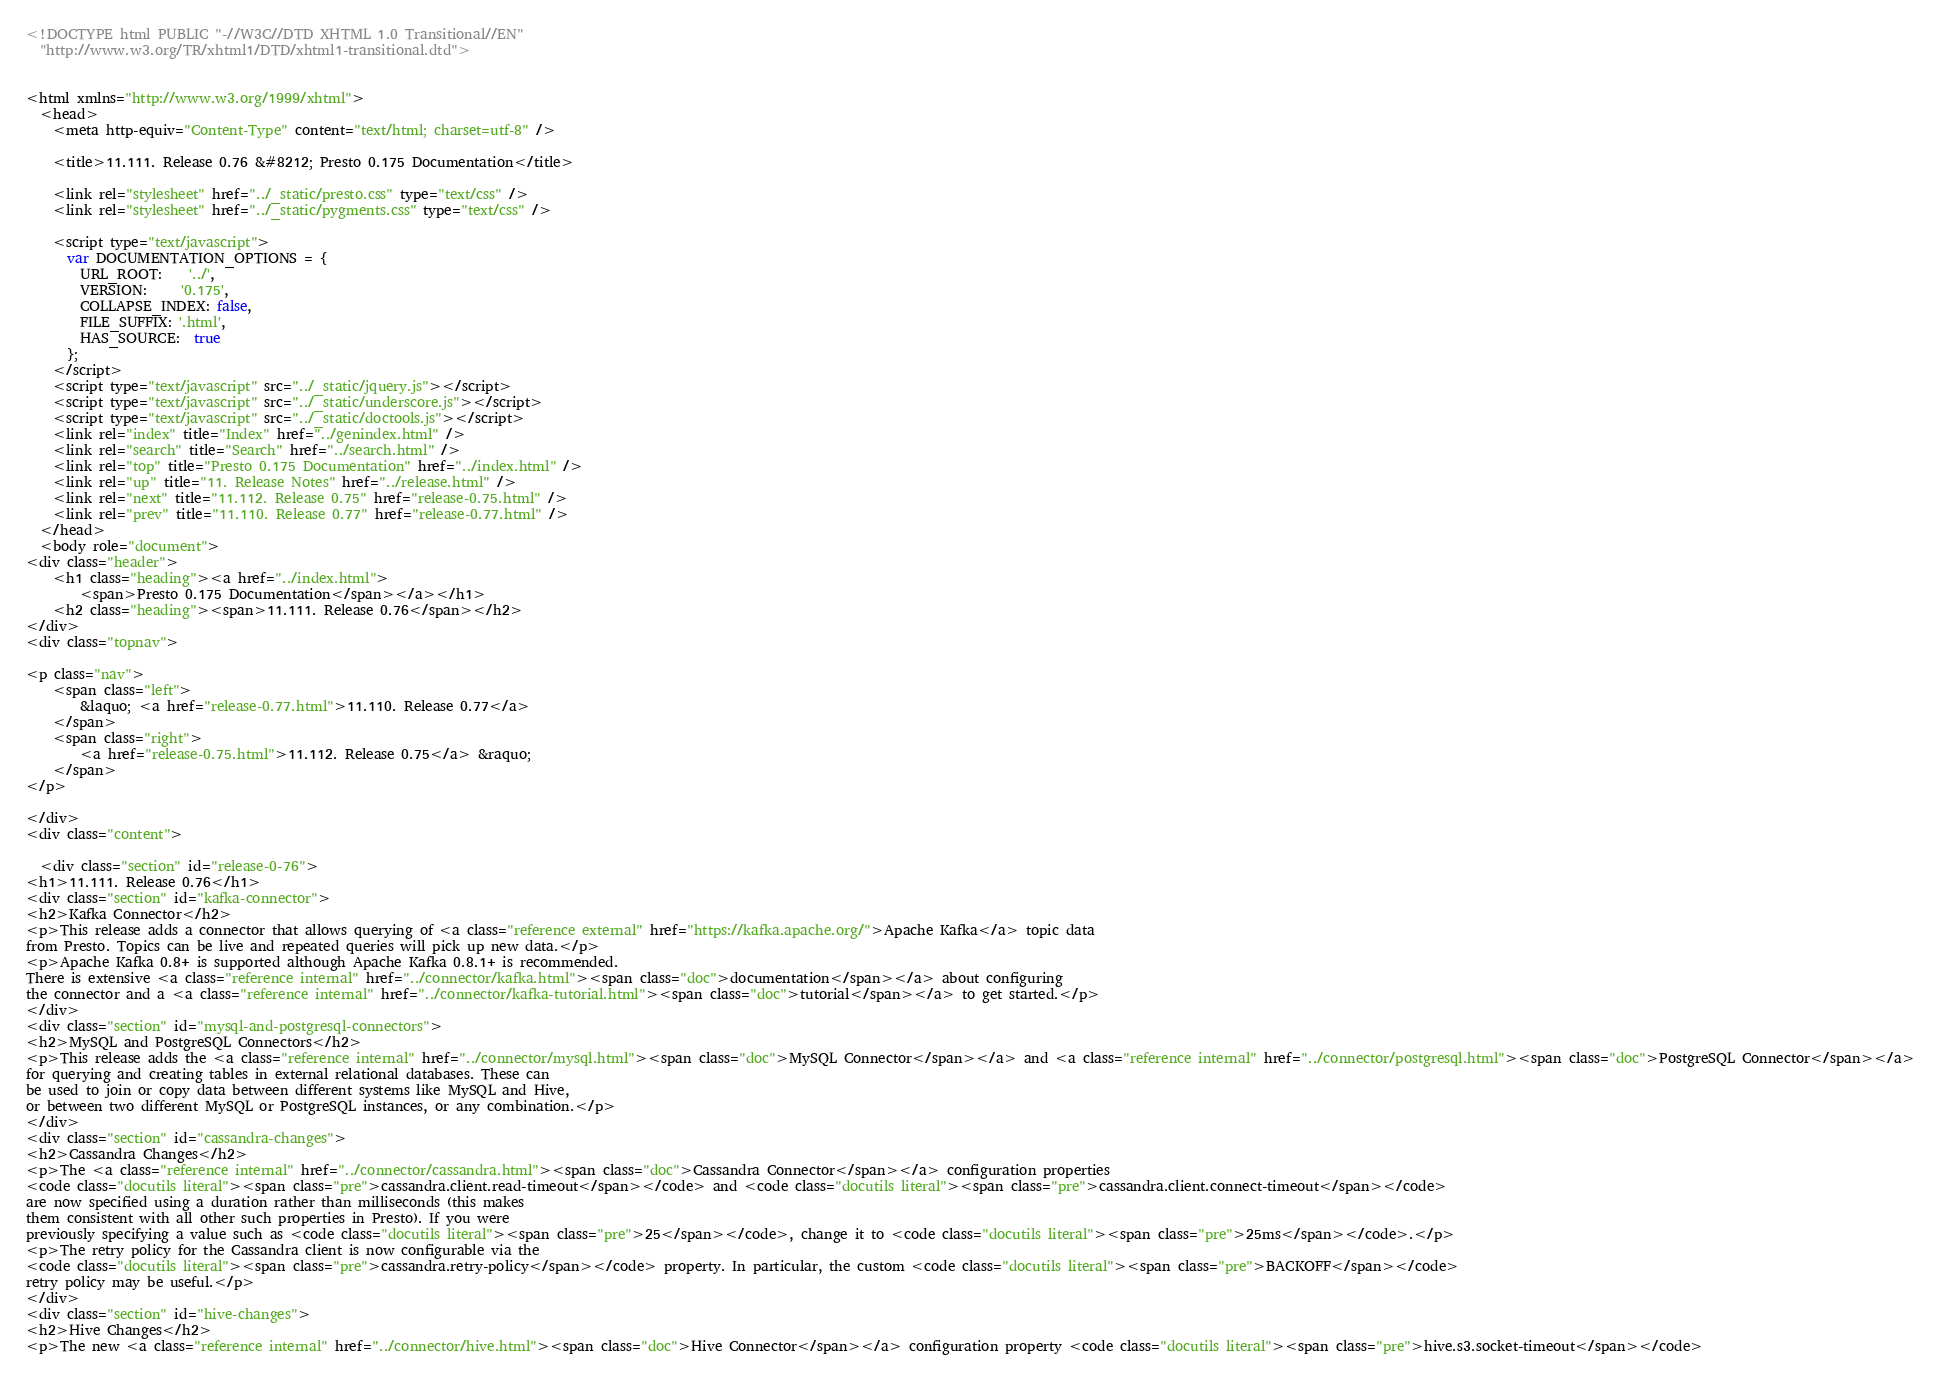Convert code to text. <code><loc_0><loc_0><loc_500><loc_500><_HTML_><!DOCTYPE html PUBLIC "-//W3C//DTD XHTML 1.0 Transitional//EN"
  "http://www.w3.org/TR/xhtml1/DTD/xhtml1-transitional.dtd">


<html xmlns="http://www.w3.org/1999/xhtml">
  <head>
    <meta http-equiv="Content-Type" content="text/html; charset=utf-8" />
    
    <title>11.111. Release 0.76 &#8212; Presto 0.175 Documentation</title>
    
    <link rel="stylesheet" href="../_static/presto.css" type="text/css" />
    <link rel="stylesheet" href="../_static/pygments.css" type="text/css" />
    
    <script type="text/javascript">
      var DOCUMENTATION_OPTIONS = {
        URL_ROOT:    '../',
        VERSION:     '0.175',
        COLLAPSE_INDEX: false,
        FILE_SUFFIX: '.html',
        HAS_SOURCE:  true
      };
    </script>
    <script type="text/javascript" src="../_static/jquery.js"></script>
    <script type="text/javascript" src="../_static/underscore.js"></script>
    <script type="text/javascript" src="../_static/doctools.js"></script>
    <link rel="index" title="Index" href="../genindex.html" />
    <link rel="search" title="Search" href="../search.html" />
    <link rel="top" title="Presto 0.175 Documentation" href="../index.html" />
    <link rel="up" title="11. Release Notes" href="../release.html" />
    <link rel="next" title="11.112. Release 0.75" href="release-0.75.html" />
    <link rel="prev" title="11.110. Release 0.77" href="release-0.77.html" /> 
  </head>
  <body role="document">
<div class="header">
    <h1 class="heading"><a href="../index.html">
        <span>Presto 0.175 Documentation</span></a></h1>
    <h2 class="heading"><span>11.111. Release 0.76</span></h2>
</div>
<div class="topnav">
    
<p class="nav">
    <span class="left">
        &laquo; <a href="release-0.77.html">11.110. Release 0.77</a>
    </span>
    <span class="right">
        <a href="release-0.75.html">11.112. Release 0.75</a> &raquo;
    </span>
</p>

</div>
<div class="content">
    
  <div class="section" id="release-0-76">
<h1>11.111. Release 0.76</h1>
<div class="section" id="kafka-connector">
<h2>Kafka Connector</h2>
<p>This release adds a connector that allows querying of <a class="reference external" href="https://kafka.apache.org/">Apache Kafka</a> topic data
from Presto. Topics can be live and repeated queries will pick up new data.</p>
<p>Apache Kafka 0.8+ is supported although Apache Kafka 0.8.1+ is recommended.
There is extensive <a class="reference internal" href="../connector/kafka.html"><span class="doc">documentation</span></a> about configuring
the connector and a <a class="reference internal" href="../connector/kafka-tutorial.html"><span class="doc">tutorial</span></a> to get started.</p>
</div>
<div class="section" id="mysql-and-postgresql-connectors">
<h2>MySQL and PostgreSQL Connectors</h2>
<p>This release adds the <a class="reference internal" href="../connector/mysql.html"><span class="doc">MySQL Connector</span></a> and <a class="reference internal" href="../connector/postgresql.html"><span class="doc">PostgreSQL Connector</span></a>
for querying and creating tables in external relational databases. These can
be used to join or copy data between different systems like MySQL and Hive,
or between two different MySQL or PostgreSQL instances, or any combination.</p>
</div>
<div class="section" id="cassandra-changes">
<h2>Cassandra Changes</h2>
<p>The <a class="reference internal" href="../connector/cassandra.html"><span class="doc">Cassandra Connector</span></a> configuration properties
<code class="docutils literal"><span class="pre">cassandra.client.read-timeout</span></code> and <code class="docutils literal"><span class="pre">cassandra.client.connect-timeout</span></code>
are now specified using a duration rather than milliseconds (this makes
them consistent with all other such properties in Presto). If you were
previously specifying a value such as <code class="docutils literal"><span class="pre">25</span></code>, change it to <code class="docutils literal"><span class="pre">25ms</span></code>.</p>
<p>The retry policy for the Cassandra client is now configurable via the
<code class="docutils literal"><span class="pre">cassandra.retry-policy</span></code> property. In particular, the custom <code class="docutils literal"><span class="pre">BACKOFF</span></code>
retry policy may be useful.</p>
</div>
<div class="section" id="hive-changes">
<h2>Hive Changes</h2>
<p>The new <a class="reference internal" href="../connector/hive.html"><span class="doc">Hive Connector</span></a> configuration property <code class="docutils literal"><span class="pre">hive.s3.socket-timeout</span></code></code> 